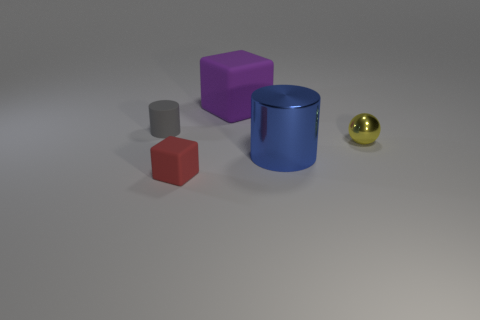Add 1 big purple matte blocks. How many objects exist? 6 Subtract all spheres. How many objects are left? 4 Subtract 0 cyan spheres. How many objects are left? 5 Subtract all purple matte blocks. Subtract all cylinders. How many objects are left? 2 Add 5 big purple objects. How many big purple objects are left? 6 Add 1 rubber blocks. How many rubber blocks exist? 3 